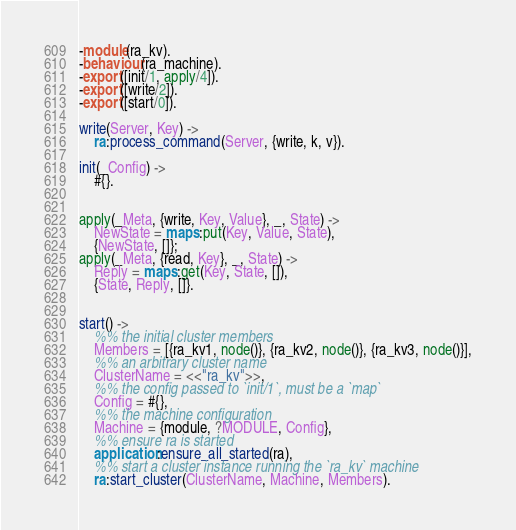<code> <loc_0><loc_0><loc_500><loc_500><_Erlang_>-module(ra_kv).
-behaviour(ra_machine).
-export([init/1, apply/4]).
-export([write/2]).
-export([start/0]).

write(Server, Key) ->
    ra:process_command(Server, {write, k, v}).

init(_Config) ->
    #{}.


apply(_Meta, {write, Key, Value}, _, State) ->
    NewState = maps:put(Key, Value, State),
    {NewState, []};
apply(_Meta, {read, Key}, _, State) ->
    Reply = maps:get(Key, State, []),
    {State, Reply, []}.


start() ->
    %% the initial cluster members
    Members = [{ra_kv1, node()}, {ra_kv2, node()}, {ra_kv3, node()}],
    %% an arbitrary cluster name
    ClusterName = <<"ra_kv">>,
    %% the config passed to `init/1`, must be a `map`
    Config = #{},
    %% the machine configuration
    Machine = {module, ?MODULE, Config},
    %% ensure ra is started
    application:ensure_all_started(ra),
    %% start a cluster instance running the `ra_kv` machine
    ra:start_cluster(ClusterName, Machine, Members).

</code> 